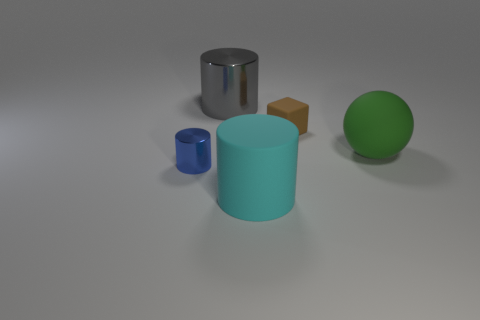How many tiny brown cubes have the same material as the gray cylinder?
Make the answer very short. 0. There is a cube; is its size the same as the metallic cylinder that is behind the small block?
Your response must be concise. No. There is a cylinder that is behind the big object that is on the right side of the large rubber thing that is in front of the large ball; what is its size?
Keep it short and to the point. Large. Is the number of tiny brown rubber cubes in front of the large sphere greater than the number of large cyan cylinders to the left of the gray cylinder?
Ensure brevity in your answer.  No. There is a metal thing that is in front of the rubber cube; what number of small rubber things are to the left of it?
Keep it short and to the point. 0. Are there any matte objects that have the same color as the big matte sphere?
Offer a terse response. No. Do the blue thing and the gray shiny thing have the same size?
Your answer should be very brief. No. Do the rubber block and the large matte cylinder have the same color?
Make the answer very short. No. There is a cylinder on the left side of the large cylinder that is left of the cyan matte cylinder; what is its material?
Provide a succinct answer. Metal. There is another large cyan object that is the same shape as the large metal thing; what material is it?
Keep it short and to the point. Rubber. 